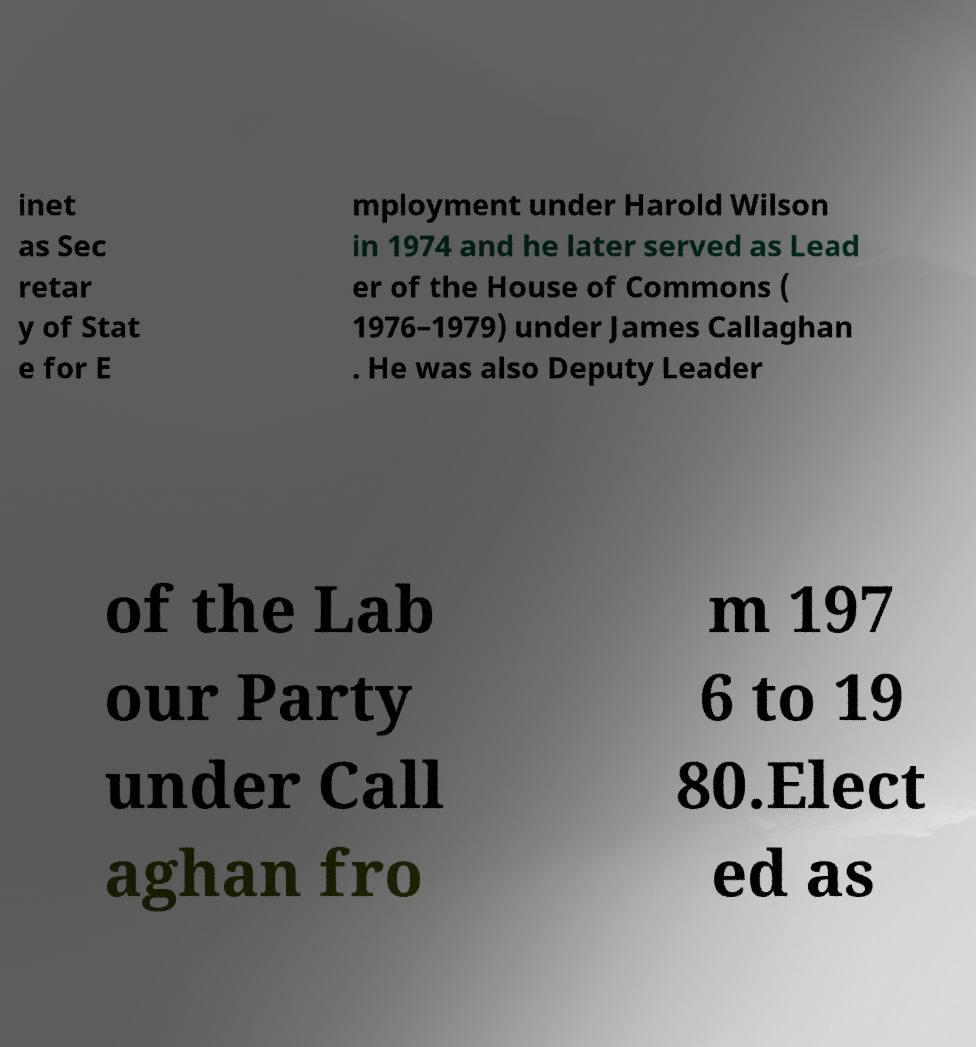Can you read and provide the text displayed in the image?This photo seems to have some interesting text. Can you extract and type it out for me? inet as Sec retar y of Stat e for E mployment under Harold Wilson in 1974 and he later served as Lead er of the House of Commons ( 1976–1979) under James Callaghan . He was also Deputy Leader of the Lab our Party under Call aghan fro m 197 6 to 19 80.Elect ed as 